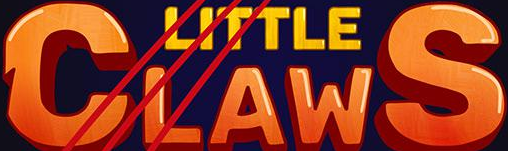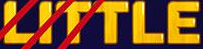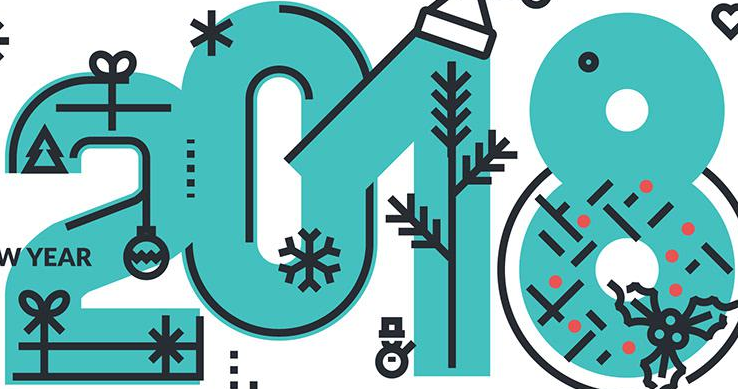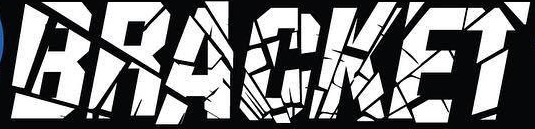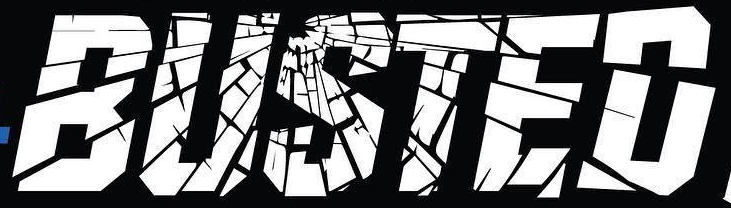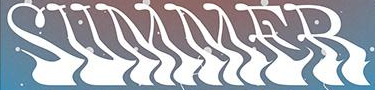What words are shown in these images in order, separated by a semicolon? CLAWS; LITTLE; 2018; BRACKET; BUSTED; SUMMER 